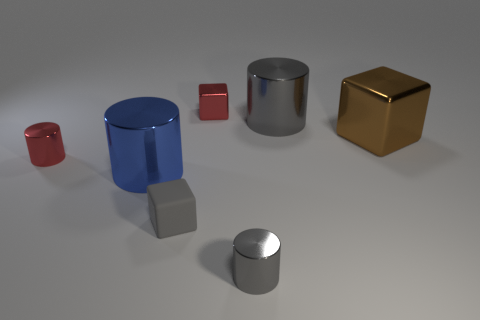Subtract all purple cylinders. Subtract all gray balls. How many cylinders are left? 4 Add 3 gray rubber cubes. How many objects exist? 10 Subtract all cylinders. How many objects are left? 3 Subtract all small rubber cubes. Subtract all tiny gray matte cubes. How many objects are left? 5 Add 4 small cylinders. How many small cylinders are left? 6 Add 6 metallic cubes. How many metallic cubes exist? 8 Subtract 0 yellow cylinders. How many objects are left? 7 